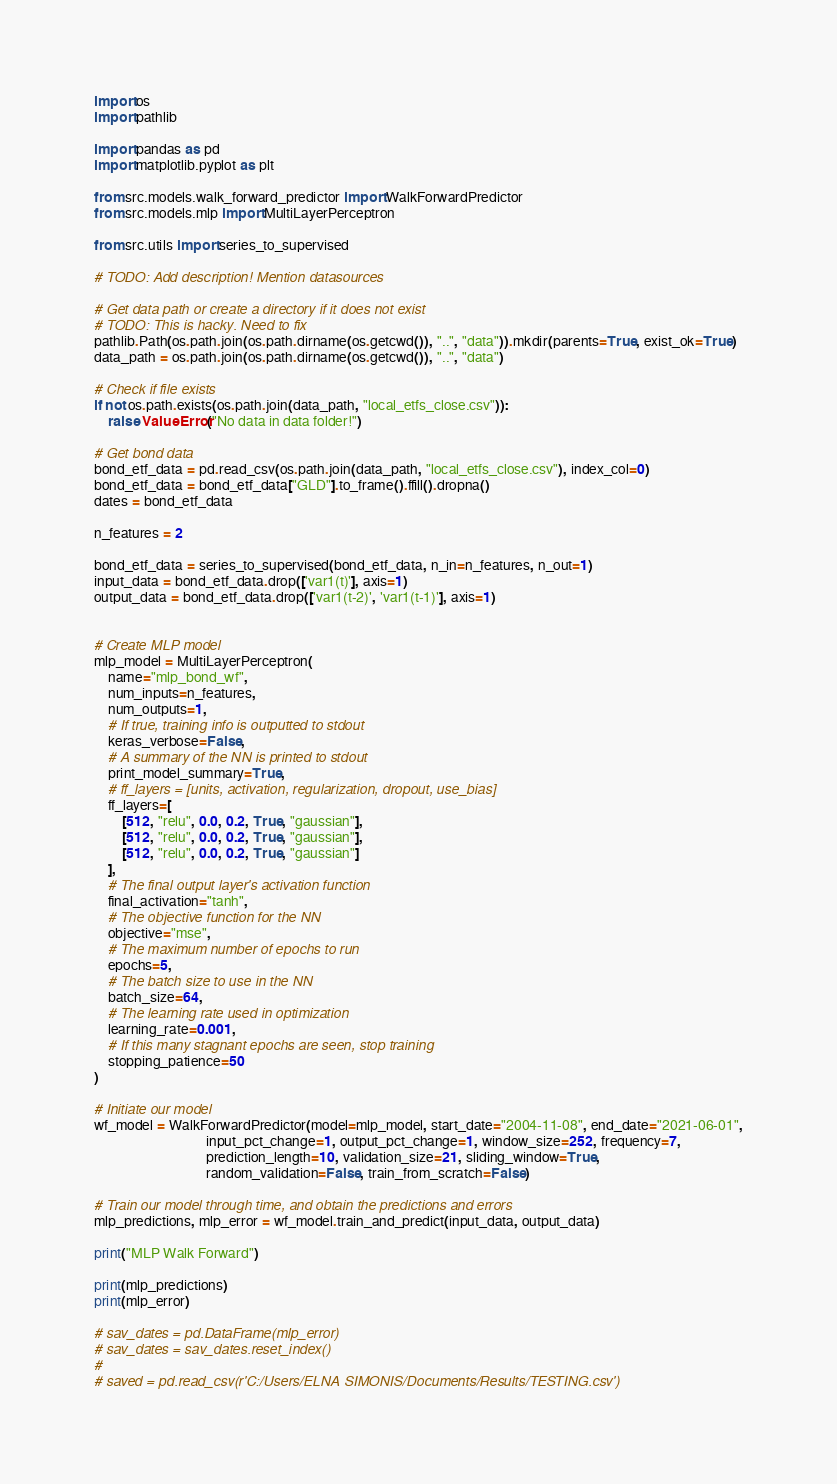Convert code to text. <code><loc_0><loc_0><loc_500><loc_500><_Python_>import os
import pathlib

import pandas as pd
import matplotlib.pyplot as plt

from src.models.walk_forward_predictor import WalkForwardPredictor
from src.models.mlp import MultiLayerPerceptron

from src.utils import series_to_supervised

# TODO: Add description! Mention datasources

# Get data path or create a directory if it does not exist
# TODO: This is hacky. Need to fix
pathlib.Path(os.path.join(os.path.dirname(os.getcwd()), "..", "data")).mkdir(parents=True, exist_ok=True)
data_path = os.path.join(os.path.dirname(os.getcwd()), "..", "data")

# Check if file exists
if not os.path.exists(os.path.join(data_path, "local_etfs_close.csv")):
    raise ValueError("No data in data folder!")

# Get bond data
bond_etf_data = pd.read_csv(os.path.join(data_path, "local_etfs_close.csv"), index_col=0)
bond_etf_data = bond_etf_data["GLD"].to_frame().ffill().dropna()
dates = bond_etf_data

n_features = 2

bond_etf_data = series_to_supervised(bond_etf_data, n_in=n_features, n_out=1)
input_data = bond_etf_data.drop(['var1(t)'], axis=1)
output_data = bond_etf_data.drop(['var1(t-2)', 'var1(t-1)'], axis=1)


# Create MLP model
mlp_model = MultiLayerPerceptron(
    name="mlp_bond_wf",
    num_inputs=n_features,
    num_outputs=1,
    # If true, training info is outputted to stdout
    keras_verbose=False,
    # A summary of the NN is printed to stdout
    print_model_summary=True,
    # ff_layers = [units, activation, regularization, dropout, use_bias]
    ff_layers=[
        [512, "relu", 0.0, 0.2, True, "gaussian"],
        [512, "relu", 0.0, 0.2, True, "gaussian"],
        [512, "relu", 0.0, 0.2, True, "gaussian"]
    ],
    # The final output layer's activation function
    final_activation="tanh",
    # The objective function for the NN
    objective="mse",
    # The maximum number of epochs to run
    epochs=5,
    # The batch size to use in the NN
    batch_size=64,
    # The learning rate used in optimization
    learning_rate=0.001,
    # If this many stagnant epochs are seen, stop training
    stopping_patience=50
)

# Initiate our model
wf_model = WalkForwardPredictor(model=mlp_model, start_date="2004-11-08", end_date="2021-06-01",
                                input_pct_change=1, output_pct_change=1, window_size=252, frequency=7,
                                prediction_length=10, validation_size=21, sliding_window=True,
                                random_validation=False, train_from_scratch=False)

# Train our model through time, and obtain the predictions and errors
mlp_predictions, mlp_error = wf_model.train_and_predict(input_data, output_data)

print("MLP Walk Forward")

print(mlp_predictions)
print(mlp_error)

# sav_dates = pd.DataFrame(mlp_error)
# sav_dates = sav_dates.reset_index()
#
# saved = pd.read_csv(r'C:/Users/ELNA SIMONIS/Documents/Results/TESTING.csv')</code> 